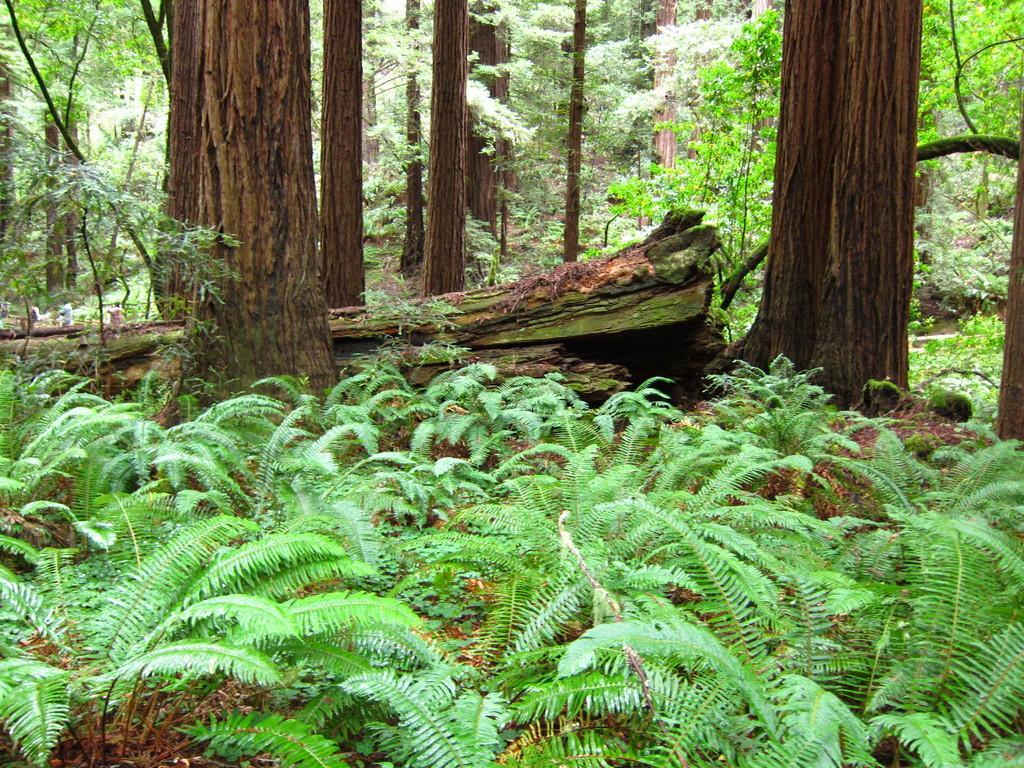How would you summarize this image in a sentence or two? In this image there are small plants at the bottom. In the middle there are tall trees one beside the other. In between the tall trees there is a tree which is fallen on the ground. 